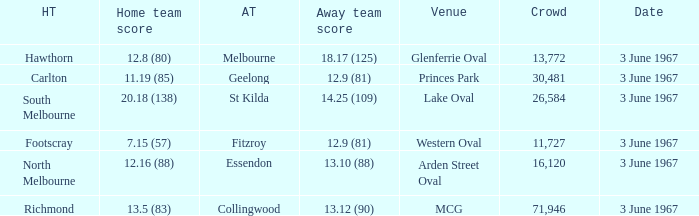Who was South Melbourne's away opponents? St Kilda. 